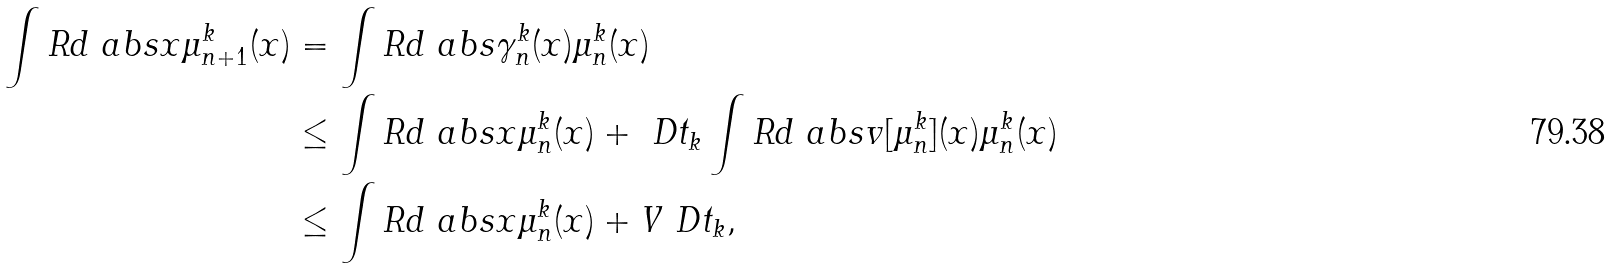Convert formula to latex. <formula><loc_0><loc_0><loc_500><loc_500>\int R d { \ a b s { x } } { \mu _ { n + 1 } ^ { k } ( x ) } & = \int R d { \ a b s { \gamma _ { n } ^ { k } ( x ) } } { \mu _ { n } ^ { k } ( x ) } \\ & \leq \int R d { \ a b s { x } } { \mu _ { n } ^ { k } ( x ) } + \ D t _ { k } \int R d { \ a b s { v [ \mu _ { n } ^ { k } ] ( x ) } } { \mu _ { n } ^ { k } ( x ) } \\ & \leq \int R d { \ a b s { x } } { \mu _ { n } ^ { k } ( x ) } + V \ D t _ { k } ,</formula> 